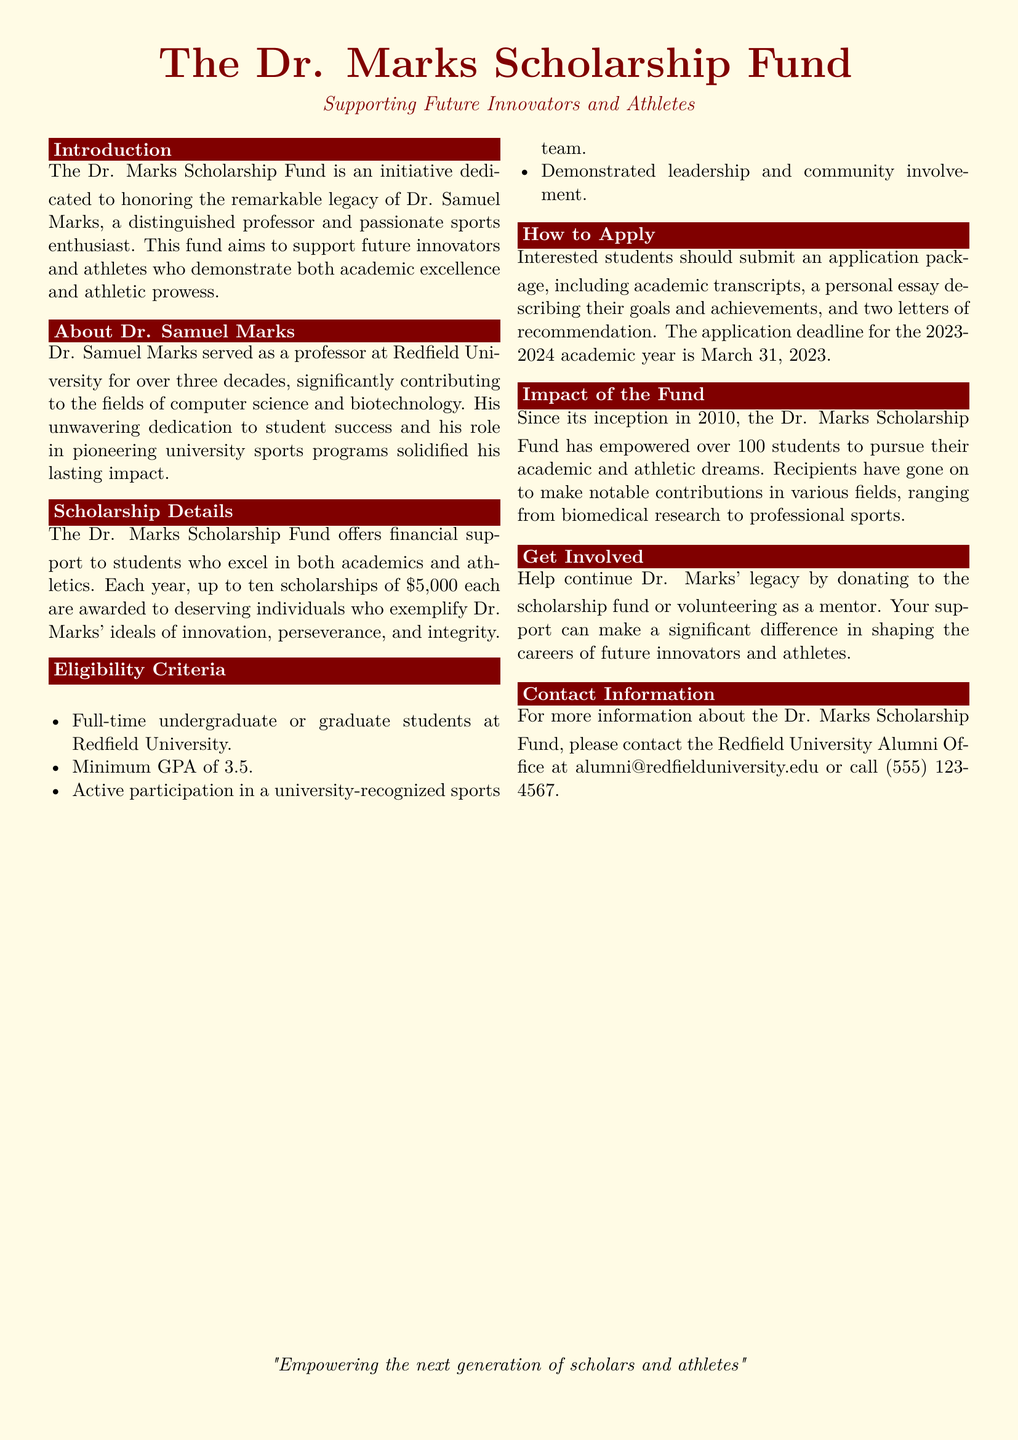What is the scholarship amount? The scholarship amount is specifically listed in the document under the "Scholarship Details" section.
Answer: $5,000 How many scholarships are awarded each year? The document states the number of scholarships available under the "Scholarship Details."
Answer: Up to ten What is the application deadline for the 2023-2024 academic year? The application deadline is mentioned in the "How to Apply" section of the document.
Answer: March 31, 2023 What is the minimum GPA required for eligibility? The eligibility criteria section lists the minimum GPA required for applicants.
Answer: 3.5 Since what year has the Dr. Marks Scholarship Fund been established? The document indicates the year the fund was established under the "Impact of the Fund" section.
Answer: 2010 Who is the scholarship fund named after? The document mentions the name of the individual honored by the scholarship fund in the introduction and about section.
Answer: Dr. Samuel Marks What type of students is eligible for this scholarship? The eligibility criteria section specifies the student types eligible for the scholarship.
Answer: Full-time undergraduate or graduate students What is one of the criteria for eligibility besides GPA? The eligibility criteria section lists the required conditions for applicants, including participation in sports.
Answer: Active participation in a university-recognized sports team How can individuals contribute to the scholarship fund? The "Get Involved" section outlines ways to support the scholarship fund.
Answer: Donating or volunteering 